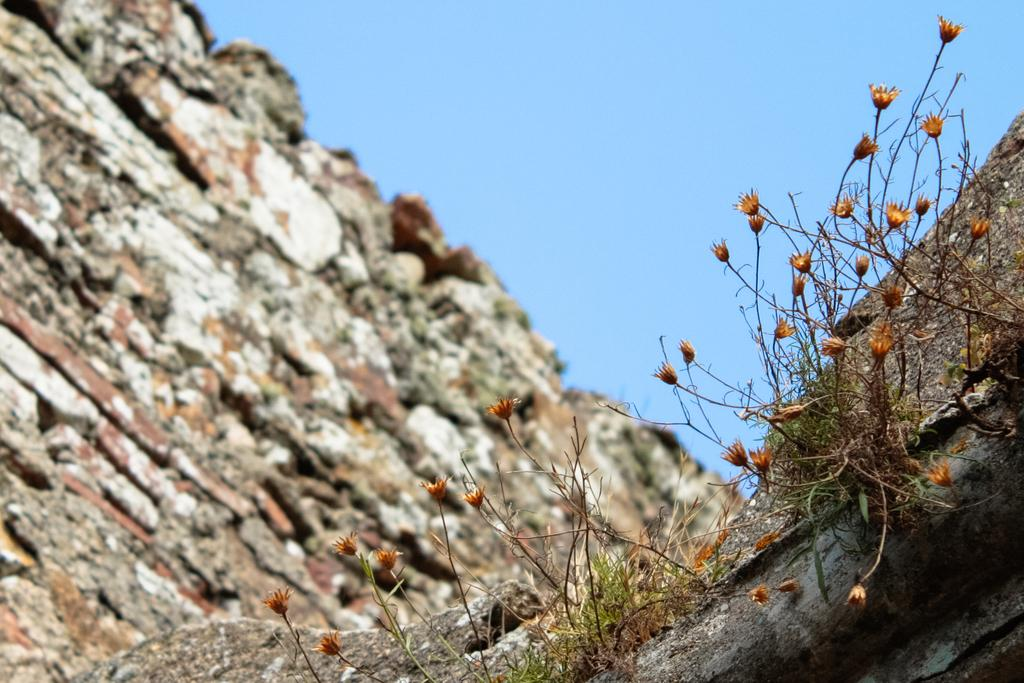What type of natural elements can be seen in the image? There are rocks in the image. What type of plant life is present in the image? There are flowers in the image. What type of list can be seen in the image? There is no list present in the image. What type of drum is visible in the image? There is no drum present in the image. 